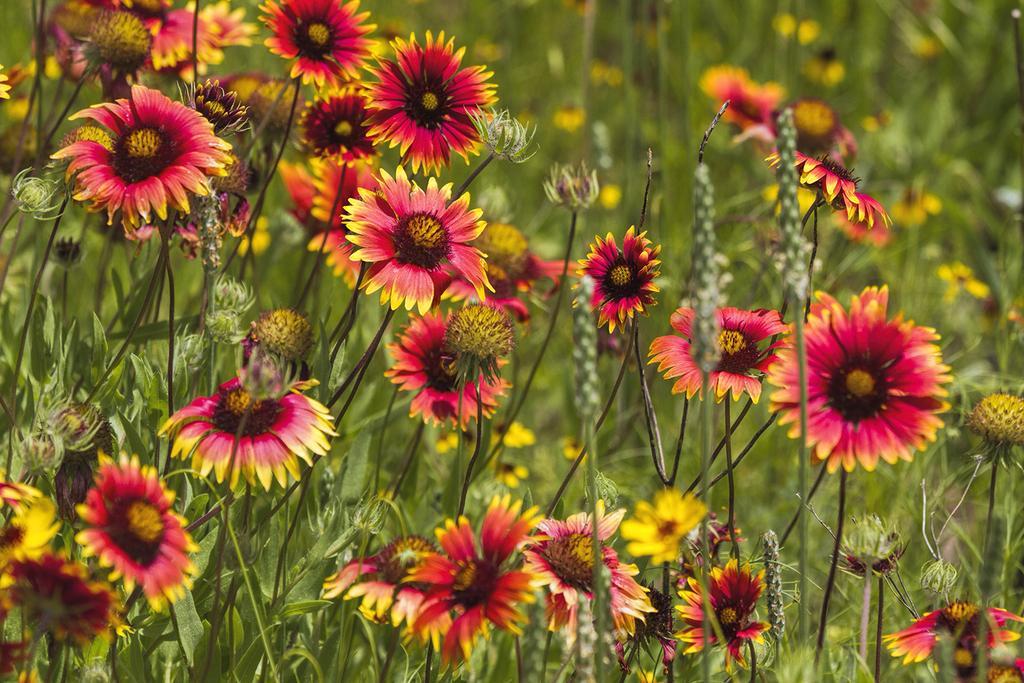How would you summarize this image in a sentence or two? In this image in the foreground there are some flowers and plants. 